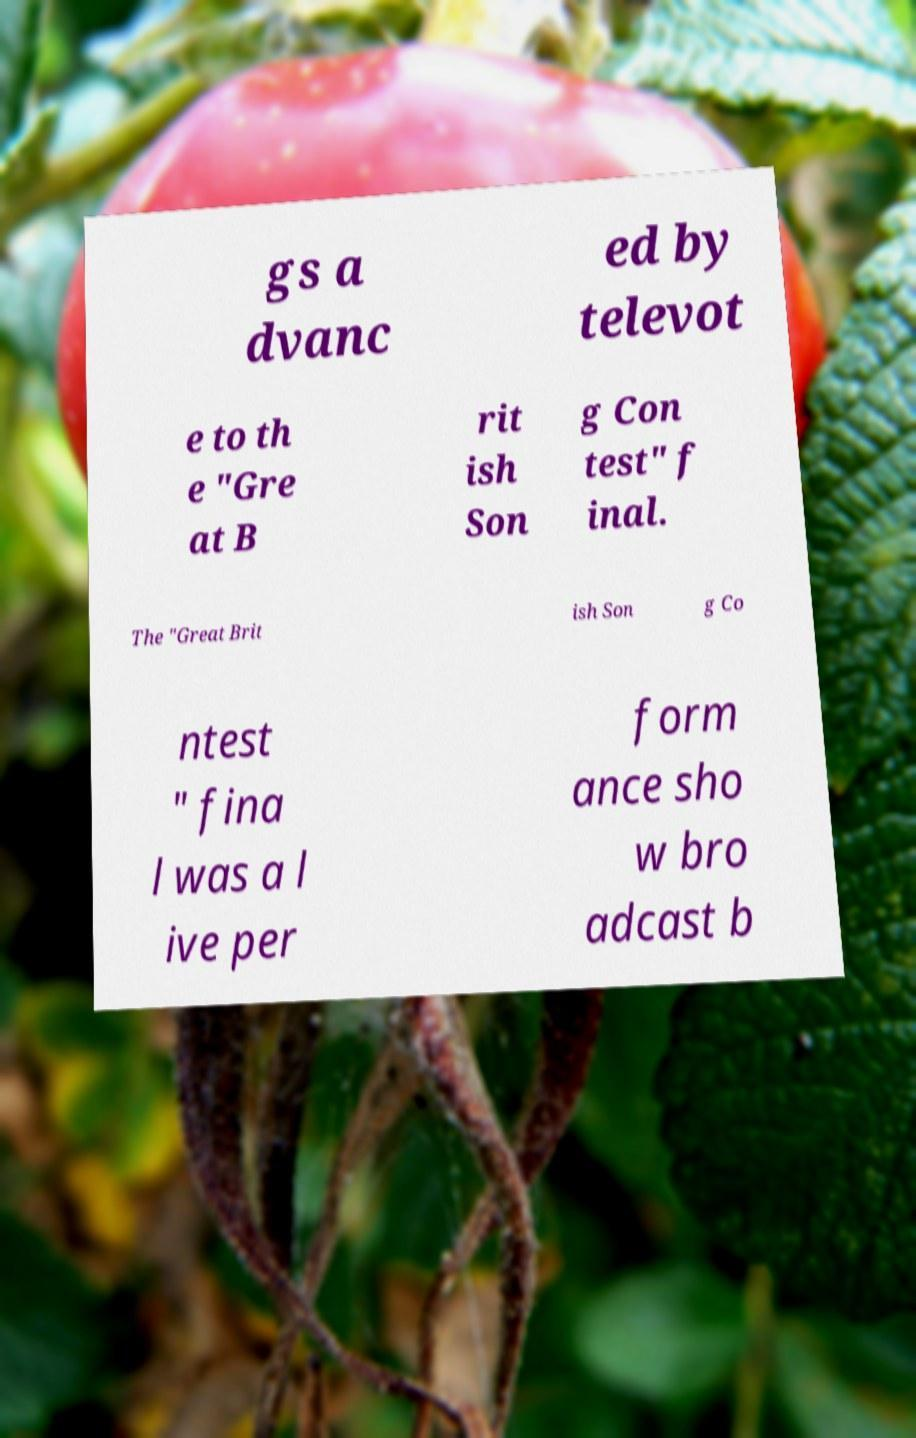There's text embedded in this image that I need extracted. Can you transcribe it verbatim? gs a dvanc ed by televot e to th e "Gre at B rit ish Son g Con test" f inal. The "Great Brit ish Son g Co ntest " fina l was a l ive per form ance sho w bro adcast b 